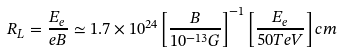<formula> <loc_0><loc_0><loc_500><loc_500>R _ { L } = \frac { E _ { e } } { e B } \simeq 1 . 7 \times 1 0 ^ { 2 4 } \left [ \frac { B } { 1 0 ^ { - 1 3 } G } \right ] ^ { - 1 } \left [ \frac { E _ { e } } { 5 0 T e V } \right ] c m</formula> 